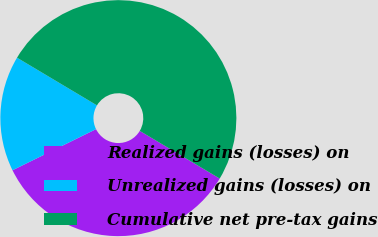<chart> <loc_0><loc_0><loc_500><loc_500><pie_chart><fcel>Realized gains (losses) on<fcel>Unrealized gains (losses) on<fcel>Cumulative net pre-tax gains<nl><fcel>34.16%<fcel>15.84%<fcel>50.0%<nl></chart> 